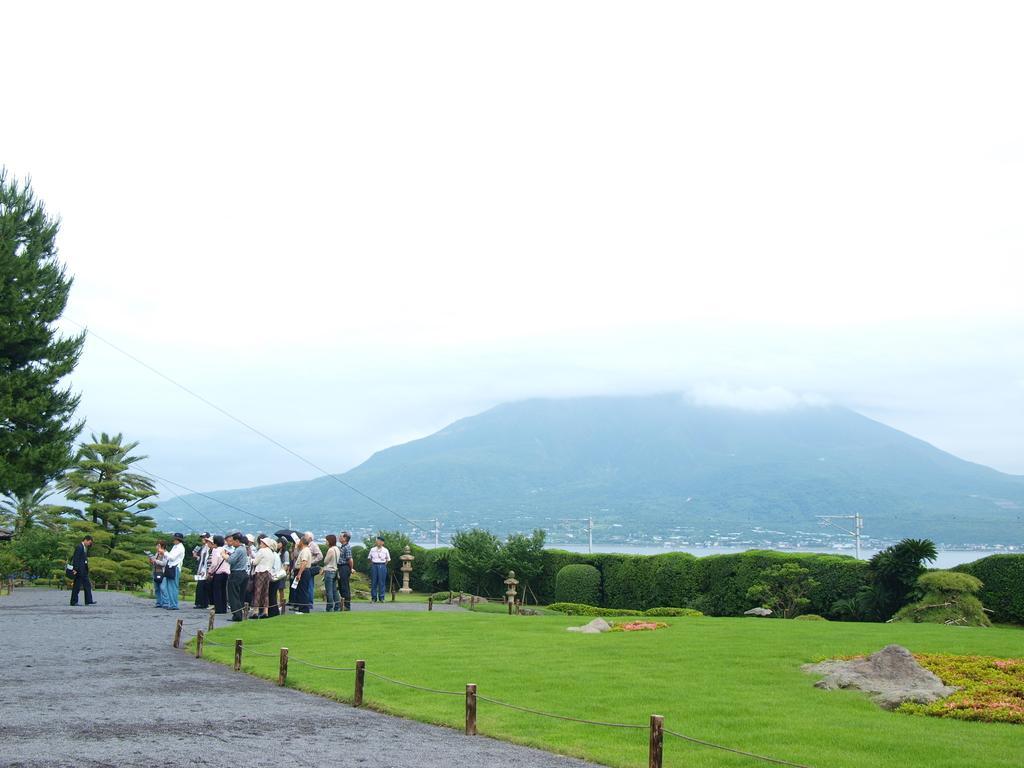Please provide a concise description of this image. In the image we can see there are people standing and the ground is covered with grass. Behind there are trees and there are bushes. 